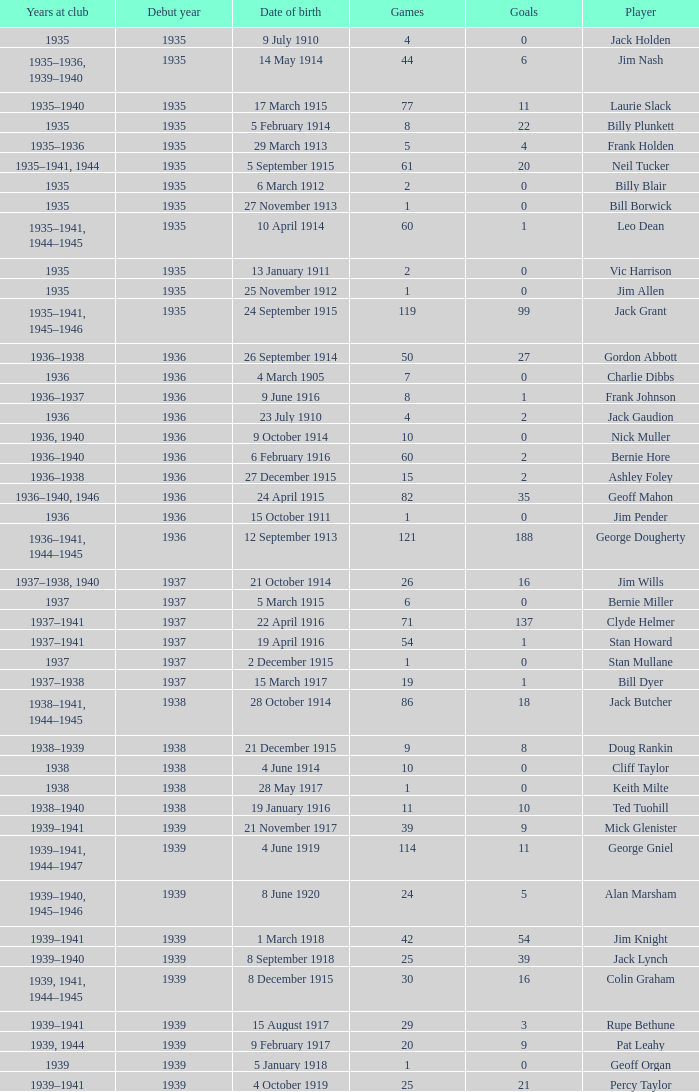What is the average games a player born on 17 March 1915 and debut before 1935 had? None. 